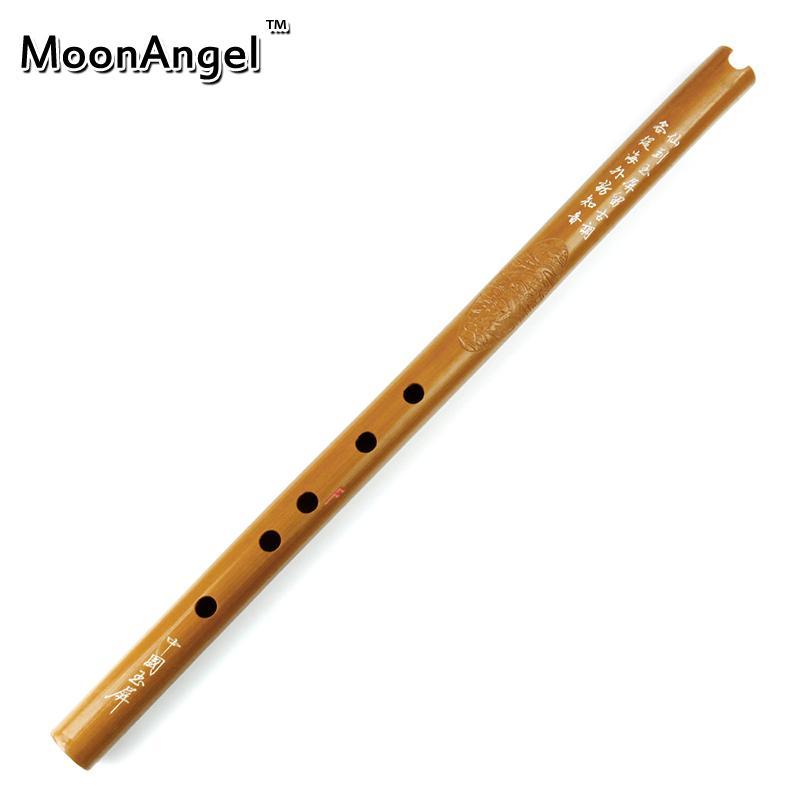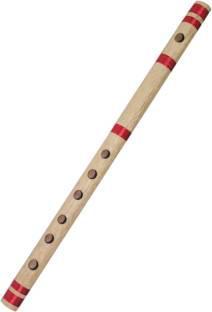The first image is the image on the left, the second image is the image on the right. Examine the images to the left and right. Is the description "There are two flutes." accurate? Answer yes or no. Yes. The first image is the image on the left, the second image is the image on the right. For the images displayed, is the sentence "There is one flute with red stripes and one flute without stripes." factually correct? Answer yes or no. Yes. 